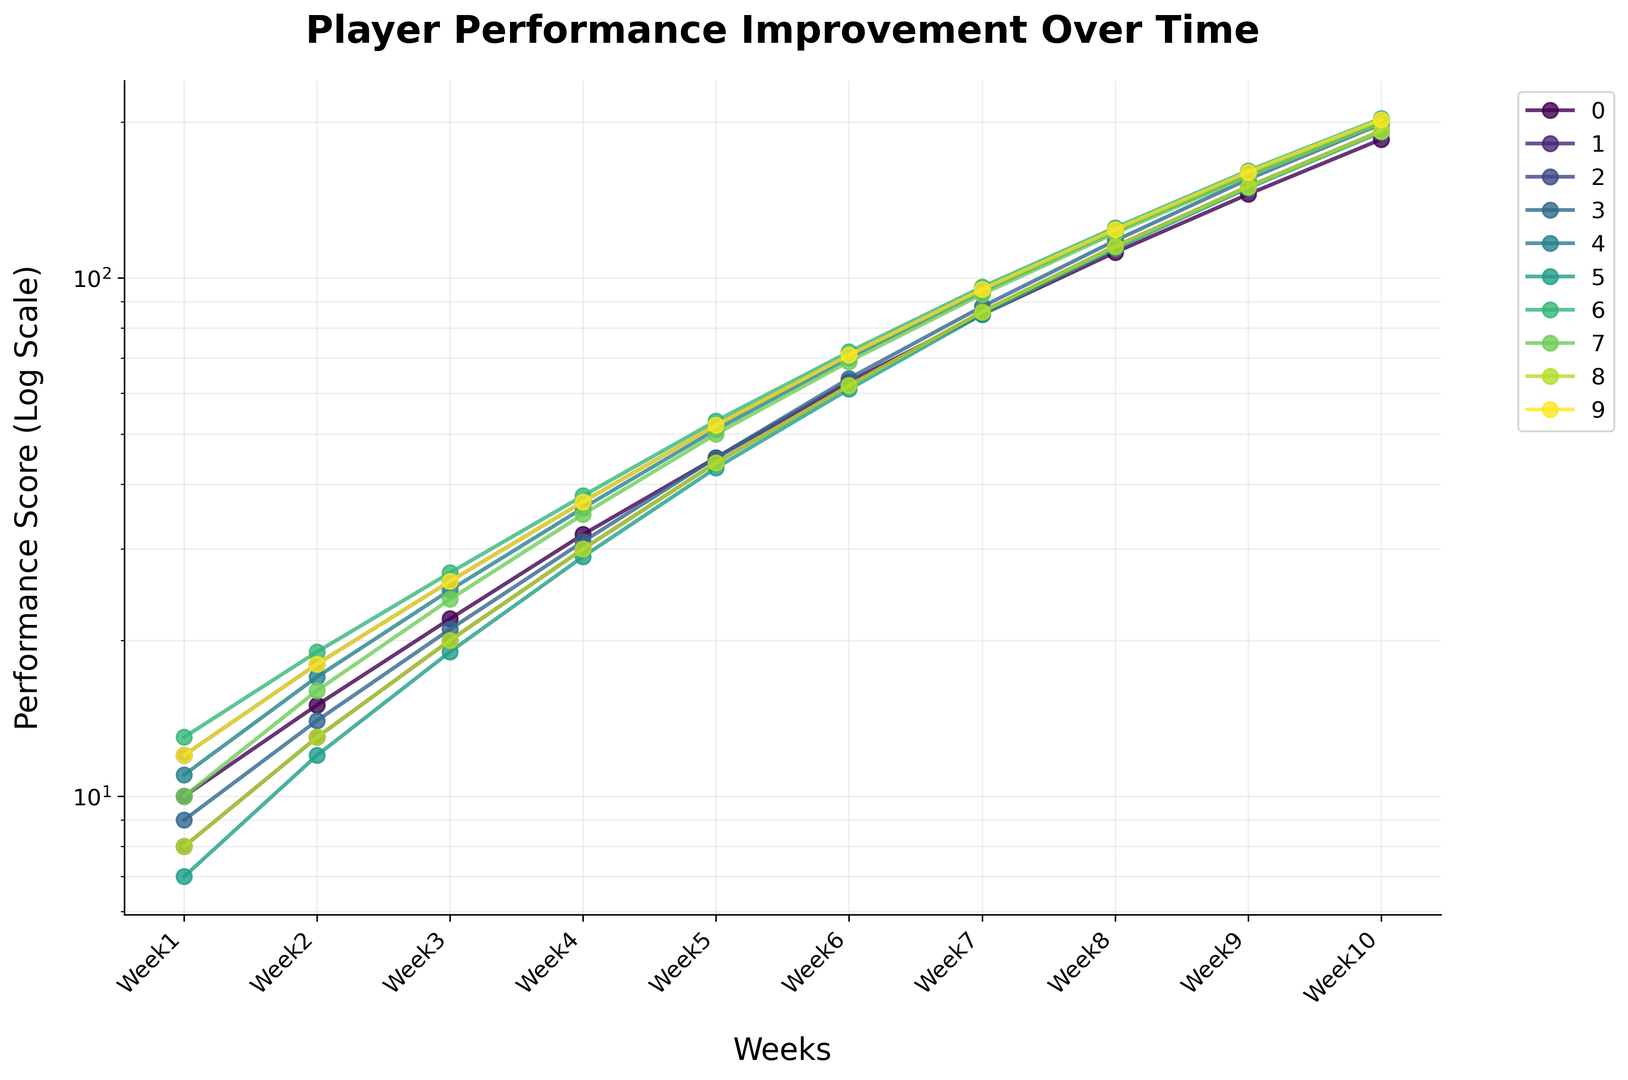Which player showed the highest improvement in performance score from Week 1 to Week 10? To find the player with the highest improvement, we need to look at the difference in their scores from Week 1 to Week 10. Wilson improved from 13 to 203, a 190-point increase, which is higher than any other player.
Answer: Wilson How does Johnson's performance in Week 10 compare to Smith's performance in Week 10? Johnson's performance score in Week 10 is 192, while Smith's score is 185. So Johnson scored higher than Smith in Week 10.
Answer: Johnson's is higher Which player had the lowest performance score in Week 5? To find the player with the lowest score in Week 5, look at the Week 5 values. Miller had the lowest score with 43.
Answer: Miller What is the average performance score of Williams in the first 5 weeks? Sum the scores of Williams from Week 1 to Week 5 and divide by 5: (12 + 18 + 26 + 37 + 52) / 5 = 145 / 5 = 29.
Answer: 29 Compare the overall trend of Davis and Moore. Who had a steeper increase in their performance scores over the weeks? By observing the graph, both Davis and Moore started from nearly similar points but Davis ends slightly higher in the logarithmic scale, thus having a steeper increase.
Answer: Davis Which week shows the overall highest performance average among all players? Calculate the average performance score for each week and compare. Week 10 has scores such as 185, 192, 202, etc., leading to the highest average performance.
Answer: Week 10 Did any player's performance score remain unchanged at any point? Observing the lines on the chart, none of the player's performance scores remained unchanged from week to week.
Answer: No Who has the closest performance score to Wilson in Week 7? In Week 7, Wilson’s score was 96. The closest score to 96 in Week 7 is Williams with 95.
Answer: Williams How many players had a performance score above 150 by Week 9? From the data, Smith, Johnson, Williams, Brown, Davis, Miller, Wilson, Moore, Taylor, and Anderson all had scores above 150 in Week 9. That's 10 players.
Answer: 10 players Which player's performance scores follow a similar pattern to Taylor's across all weeks? Johnson and Taylor have similar performance scores, when comparing each week's scores, they are very close to each other.
Answer: Johnson 